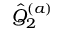Convert formula to latex. <formula><loc_0><loc_0><loc_500><loc_500>{ \hat { Q } } _ { 2 } ^ { ( a ) }</formula> 